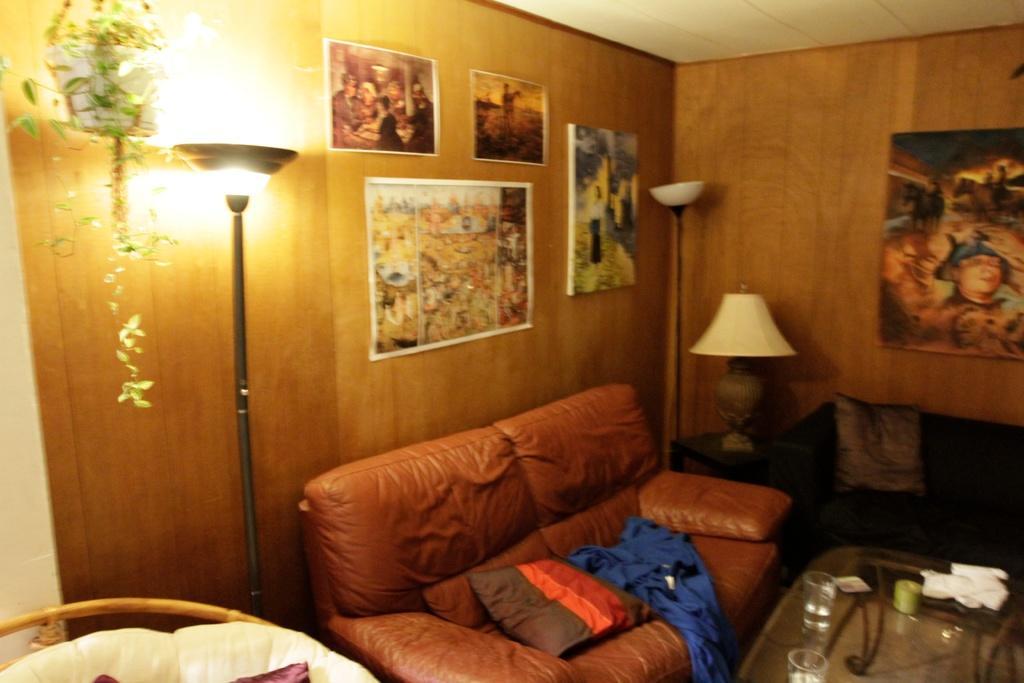How would you summarize this image in a sentence or two? The picture is taken in a room. At the bottom of the picture there are couches, pillows, desk, glasses, paper and lamps. At the top there are posters, framed, house plant and a wall. Towards right at the top it is ceiling. 